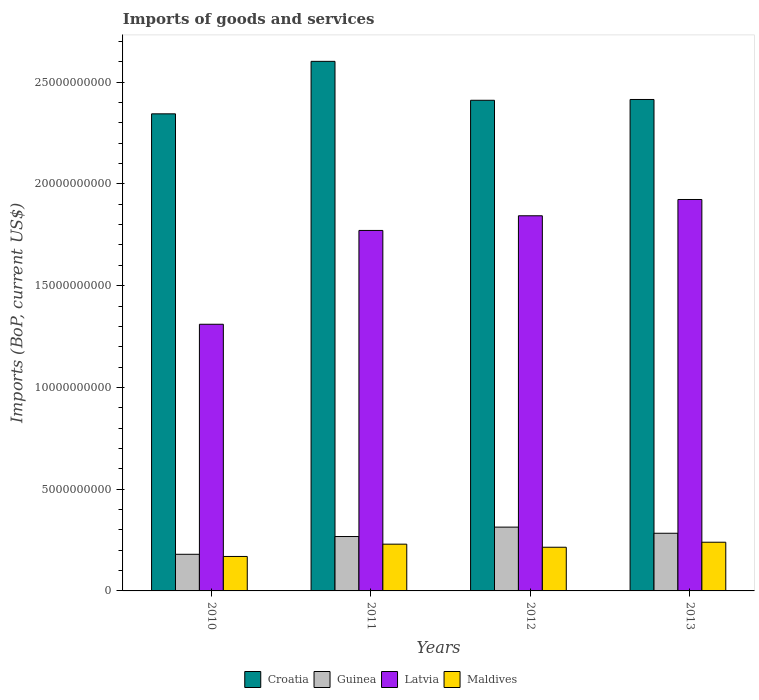Are the number of bars per tick equal to the number of legend labels?
Your response must be concise. Yes. Are the number of bars on each tick of the X-axis equal?
Your answer should be compact. Yes. What is the amount spent on imports in Guinea in 2010?
Your answer should be very brief. 1.80e+09. Across all years, what is the maximum amount spent on imports in Croatia?
Give a very brief answer. 2.60e+1. Across all years, what is the minimum amount spent on imports in Croatia?
Ensure brevity in your answer.  2.34e+1. In which year was the amount spent on imports in Maldives minimum?
Provide a succinct answer. 2010. What is the total amount spent on imports in Latvia in the graph?
Make the answer very short. 6.85e+1. What is the difference between the amount spent on imports in Maldives in 2010 and that in 2011?
Give a very brief answer. -6.05e+08. What is the difference between the amount spent on imports in Maldives in 2012 and the amount spent on imports in Latvia in 2013?
Provide a short and direct response. -1.71e+1. What is the average amount spent on imports in Latvia per year?
Keep it short and to the point. 1.71e+1. In the year 2011, what is the difference between the amount spent on imports in Guinea and amount spent on imports in Maldives?
Your answer should be compact. 3.75e+08. In how many years, is the amount spent on imports in Guinea greater than 8000000000 US$?
Your answer should be compact. 0. What is the ratio of the amount spent on imports in Latvia in 2011 to that in 2013?
Provide a succinct answer. 0.92. Is the amount spent on imports in Guinea in 2010 less than that in 2013?
Offer a very short reply. Yes. Is the difference between the amount spent on imports in Guinea in 2010 and 2013 greater than the difference between the amount spent on imports in Maldives in 2010 and 2013?
Your answer should be very brief. No. What is the difference between the highest and the second highest amount spent on imports in Guinea?
Ensure brevity in your answer.  3.02e+08. What is the difference between the highest and the lowest amount spent on imports in Maldives?
Give a very brief answer. 7.00e+08. Is the sum of the amount spent on imports in Croatia in 2010 and 2012 greater than the maximum amount spent on imports in Maldives across all years?
Your response must be concise. Yes. Is it the case that in every year, the sum of the amount spent on imports in Croatia and amount spent on imports in Guinea is greater than the sum of amount spent on imports in Maldives and amount spent on imports in Latvia?
Your answer should be very brief. Yes. What does the 3rd bar from the left in 2011 represents?
Your response must be concise. Latvia. What does the 4th bar from the right in 2010 represents?
Provide a succinct answer. Croatia. Is it the case that in every year, the sum of the amount spent on imports in Croatia and amount spent on imports in Maldives is greater than the amount spent on imports in Guinea?
Offer a very short reply. Yes. How many bars are there?
Give a very brief answer. 16. How many years are there in the graph?
Ensure brevity in your answer.  4. What is the difference between two consecutive major ticks on the Y-axis?
Your answer should be very brief. 5.00e+09. Where does the legend appear in the graph?
Offer a very short reply. Bottom center. How many legend labels are there?
Give a very brief answer. 4. How are the legend labels stacked?
Provide a short and direct response. Horizontal. What is the title of the graph?
Give a very brief answer. Imports of goods and services. What is the label or title of the Y-axis?
Keep it short and to the point. Imports (BoP, current US$). What is the Imports (BoP, current US$) in Croatia in 2010?
Ensure brevity in your answer.  2.34e+1. What is the Imports (BoP, current US$) in Guinea in 2010?
Offer a very short reply. 1.80e+09. What is the Imports (BoP, current US$) of Latvia in 2010?
Keep it short and to the point. 1.31e+1. What is the Imports (BoP, current US$) of Maldives in 2010?
Your response must be concise. 1.69e+09. What is the Imports (BoP, current US$) in Croatia in 2011?
Make the answer very short. 2.60e+1. What is the Imports (BoP, current US$) in Guinea in 2011?
Your response must be concise. 2.67e+09. What is the Imports (BoP, current US$) of Latvia in 2011?
Provide a short and direct response. 1.77e+1. What is the Imports (BoP, current US$) in Maldives in 2011?
Your answer should be compact. 2.30e+09. What is the Imports (BoP, current US$) in Croatia in 2012?
Provide a succinct answer. 2.41e+1. What is the Imports (BoP, current US$) of Guinea in 2012?
Provide a succinct answer. 3.14e+09. What is the Imports (BoP, current US$) in Latvia in 2012?
Give a very brief answer. 1.84e+1. What is the Imports (BoP, current US$) of Maldives in 2012?
Ensure brevity in your answer.  2.15e+09. What is the Imports (BoP, current US$) of Croatia in 2013?
Offer a terse response. 2.42e+1. What is the Imports (BoP, current US$) in Guinea in 2013?
Ensure brevity in your answer.  2.83e+09. What is the Imports (BoP, current US$) in Latvia in 2013?
Your response must be concise. 1.92e+1. What is the Imports (BoP, current US$) of Maldives in 2013?
Offer a terse response. 2.39e+09. Across all years, what is the maximum Imports (BoP, current US$) in Croatia?
Your answer should be very brief. 2.60e+1. Across all years, what is the maximum Imports (BoP, current US$) in Guinea?
Give a very brief answer. 3.14e+09. Across all years, what is the maximum Imports (BoP, current US$) of Latvia?
Your answer should be very brief. 1.92e+1. Across all years, what is the maximum Imports (BoP, current US$) of Maldives?
Your answer should be very brief. 2.39e+09. Across all years, what is the minimum Imports (BoP, current US$) in Croatia?
Make the answer very short. 2.34e+1. Across all years, what is the minimum Imports (BoP, current US$) of Guinea?
Your response must be concise. 1.80e+09. Across all years, what is the minimum Imports (BoP, current US$) in Latvia?
Give a very brief answer. 1.31e+1. Across all years, what is the minimum Imports (BoP, current US$) of Maldives?
Provide a succinct answer. 1.69e+09. What is the total Imports (BoP, current US$) of Croatia in the graph?
Offer a terse response. 9.77e+1. What is the total Imports (BoP, current US$) of Guinea in the graph?
Ensure brevity in your answer.  1.04e+1. What is the total Imports (BoP, current US$) in Latvia in the graph?
Provide a short and direct response. 6.85e+1. What is the total Imports (BoP, current US$) of Maldives in the graph?
Your answer should be compact. 8.53e+09. What is the difference between the Imports (BoP, current US$) in Croatia in 2010 and that in 2011?
Make the answer very short. -2.58e+09. What is the difference between the Imports (BoP, current US$) in Guinea in 2010 and that in 2011?
Make the answer very short. -8.73e+08. What is the difference between the Imports (BoP, current US$) of Latvia in 2010 and that in 2011?
Your answer should be very brief. -4.61e+09. What is the difference between the Imports (BoP, current US$) in Maldives in 2010 and that in 2011?
Make the answer very short. -6.05e+08. What is the difference between the Imports (BoP, current US$) in Croatia in 2010 and that in 2012?
Your response must be concise. -6.66e+08. What is the difference between the Imports (BoP, current US$) in Guinea in 2010 and that in 2012?
Give a very brief answer. -1.34e+09. What is the difference between the Imports (BoP, current US$) of Latvia in 2010 and that in 2012?
Offer a terse response. -5.33e+09. What is the difference between the Imports (BoP, current US$) in Maldives in 2010 and that in 2012?
Keep it short and to the point. -4.53e+08. What is the difference between the Imports (BoP, current US$) in Croatia in 2010 and that in 2013?
Your answer should be compact. -7.05e+08. What is the difference between the Imports (BoP, current US$) in Guinea in 2010 and that in 2013?
Your answer should be very brief. -1.03e+09. What is the difference between the Imports (BoP, current US$) of Latvia in 2010 and that in 2013?
Your response must be concise. -6.13e+09. What is the difference between the Imports (BoP, current US$) of Maldives in 2010 and that in 2013?
Your answer should be compact. -7.00e+08. What is the difference between the Imports (BoP, current US$) of Croatia in 2011 and that in 2012?
Your answer should be compact. 1.91e+09. What is the difference between the Imports (BoP, current US$) in Guinea in 2011 and that in 2012?
Provide a short and direct response. -4.63e+08. What is the difference between the Imports (BoP, current US$) of Latvia in 2011 and that in 2012?
Your response must be concise. -7.21e+08. What is the difference between the Imports (BoP, current US$) of Maldives in 2011 and that in 2012?
Your answer should be very brief. 1.51e+08. What is the difference between the Imports (BoP, current US$) in Croatia in 2011 and that in 2013?
Offer a terse response. 1.87e+09. What is the difference between the Imports (BoP, current US$) in Guinea in 2011 and that in 2013?
Give a very brief answer. -1.60e+08. What is the difference between the Imports (BoP, current US$) in Latvia in 2011 and that in 2013?
Give a very brief answer. -1.52e+09. What is the difference between the Imports (BoP, current US$) in Maldives in 2011 and that in 2013?
Provide a short and direct response. -9.49e+07. What is the difference between the Imports (BoP, current US$) of Croatia in 2012 and that in 2013?
Provide a short and direct response. -3.94e+07. What is the difference between the Imports (BoP, current US$) in Guinea in 2012 and that in 2013?
Provide a succinct answer. 3.02e+08. What is the difference between the Imports (BoP, current US$) in Latvia in 2012 and that in 2013?
Your answer should be compact. -8.01e+08. What is the difference between the Imports (BoP, current US$) in Maldives in 2012 and that in 2013?
Your response must be concise. -2.46e+08. What is the difference between the Imports (BoP, current US$) in Croatia in 2010 and the Imports (BoP, current US$) in Guinea in 2011?
Offer a very short reply. 2.08e+1. What is the difference between the Imports (BoP, current US$) in Croatia in 2010 and the Imports (BoP, current US$) in Latvia in 2011?
Keep it short and to the point. 5.73e+09. What is the difference between the Imports (BoP, current US$) of Croatia in 2010 and the Imports (BoP, current US$) of Maldives in 2011?
Your response must be concise. 2.11e+1. What is the difference between the Imports (BoP, current US$) in Guinea in 2010 and the Imports (BoP, current US$) in Latvia in 2011?
Offer a very short reply. -1.59e+1. What is the difference between the Imports (BoP, current US$) in Guinea in 2010 and the Imports (BoP, current US$) in Maldives in 2011?
Ensure brevity in your answer.  -4.97e+08. What is the difference between the Imports (BoP, current US$) in Latvia in 2010 and the Imports (BoP, current US$) in Maldives in 2011?
Your answer should be very brief. 1.08e+1. What is the difference between the Imports (BoP, current US$) in Croatia in 2010 and the Imports (BoP, current US$) in Guinea in 2012?
Keep it short and to the point. 2.03e+1. What is the difference between the Imports (BoP, current US$) in Croatia in 2010 and the Imports (BoP, current US$) in Latvia in 2012?
Ensure brevity in your answer.  5.01e+09. What is the difference between the Imports (BoP, current US$) of Croatia in 2010 and the Imports (BoP, current US$) of Maldives in 2012?
Ensure brevity in your answer.  2.13e+1. What is the difference between the Imports (BoP, current US$) of Guinea in 2010 and the Imports (BoP, current US$) of Latvia in 2012?
Make the answer very short. -1.66e+1. What is the difference between the Imports (BoP, current US$) of Guinea in 2010 and the Imports (BoP, current US$) of Maldives in 2012?
Your answer should be compact. -3.46e+08. What is the difference between the Imports (BoP, current US$) in Latvia in 2010 and the Imports (BoP, current US$) in Maldives in 2012?
Give a very brief answer. 1.10e+1. What is the difference between the Imports (BoP, current US$) in Croatia in 2010 and the Imports (BoP, current US$) in Guinea in 2013?
Your response must be concise. 2.06e+1. What is the difference between the Imports (BoP, current US$) in Croatia in 2010 and the Imports (BoP, current US$) in Latvia in 2013?
Provide a succinct answer. 4.21e+09. What is the difference between the Imports (BoP, current US$) in Croatia in 2010 and the Imports (BoP, current US$) in Maldives in 2013?
Your response must be concise. 2.11e+1. What is the difference between the Imports (BoP, current US$) in Guinea in 2010 and the Imports (BoP, current US$) in Latvia in 2013?
Provide a succinct answer. -1.74e+1. What is the difference between the Imports (BoP, current US$) in Guinea in 2010 and the Imports (BoP, current US$) in Maldives in 2013?
Offer a very short reply. -5.92e+08. What is the difference between the Imports (BoP, current US$) of Latvia in 2010 and the Imports (BoP, current US$) of Maldives in 2013?
Provide a short and direct response. 1.07e+1. What is the difference between the Imports (BoP, current US$) in Croatia in 2011 and the Imports (BoP, current US$) in Guinea in 2012?
Ensure brevity in your answer.  2.29e+1. What is the difference between the Imports (BoP, current US$) in Croatia in 2011 and the Imports (BoP, current US$) in Latvia in 2012?
Provide a short and direct response. 7.59e+09. What is the difference between the Imports (BoP, current US$) in Croatia in 2011 and the Imports (BoP, current US$) in Maldives in 2012?
Offer a terse response. 2.39e+1. What is the difference between the Imports (BoP, current US$) in Guinea in 2011 and the Imports (BoP, current US$) in Latvia in 2012?
Your answer should be compact. -1.58e+1. What is the difference between the Imports (BoP, current US$) in Guinea in 2011 and the Imports (BoP, current US$) in Maldives in 2012?
Offer a very short reply. 5.27e+08. What is the difference between the Imports (BoP, current US$) in Latvia in 2011 and the Imports (BoP, current US$) in Maldives in 2012?
Keep it short and to the point. 1.56e+1. What is the difference between the Imports (BoP, current US$) in Croatia in 2011 and the Imports (BoP, current US$) in Guinea in 2013?
Your answer should be compact. 2.32e+1. What is the difference between the Imports (BoP, current US$) in Croatia in 2011 and the Imports (BoP, current US$) in Latvia in 2013?
Keep it short and to the point. 6.79e+09. What is the difference between the Imports (BoP, current US$) in Croatia in 2011 and the Imports (BoP, current US$) in Maldives in 2013?
Your response must be concise. 2.36e+1. What is the difference between the Imports (BoP, current US$) in Guinea in 2011 and the Imports (BoP, current US$) in Latvia in 2013?
Your answer should be compact. -1.66e+1. What is the difference between the Imports (BoP, current US$) of Guinea in 2011 and the Imports (BoP, current US$) of Maldives in 2013?
Ensure brevity in your answer.  2.80e+08. What is the difference between the Imports (BoP, current US$) of Latvia in 2011 and the Imports (BoP, current US$) of Maldives in 2013?
Your answer should be very brief. 1.53e+1. What is the difference between the Imports (BoP, current US$) of Croatia in 2012 and the Imports (BoP, current US$) of Guinea in 2013?
Keep it short and to the point. 2.13e+1. What is the difference between the Imports (BoP, current US$) in Croatia in 2012 and the Imports (BoP, current US$) in Latvia in 2013?
Offer a terse response. 4.88e+09. What is the difference between the Imports (BoP, current US$) in Croatia in 2012 and the Imports (BoP, current US$) in Maldives in 2013?
Keep it short and to the point. 2.17e+1. What is the difference between the Imports (BoP, current US$) in Guinea in 2012 and the Imports (BoP, current US$) in Latvia in 2013?
Ensure brevity in your answer.  -1.61e+1. What is the difference between the Imports (BoP, current US$) of Guinea in 2012 and the Imports (BoP, current US$) of Maldives in 2013?
Give a very brief answer. 7.43e+08. What is the difference between the Imports (BoP, current US$) of Latvia in 2012 and the Imports (BoP, current US$) of Maldives in 2013?
Give a very brief answer. 1.60e+1. What is the average Imports (BoP, current US$) in Croatia per year?
Offer a terse response. 2.44e+1. What is the average Imports (BoP, current US$) of Guinea per year?
Provide a succinct answer. 2.61e+09. What is the average Imports (BoP, current US$) of Latvia per year?
Your response must be concise. 1.71e+1. What is the average Imports (BoP, current US$) in Maldives per year?
Your response must be concise. 2.13e+09. In the year 2010, what is the difference between the Imports (BoP, current US$) of Croatia and Imports (BoP, current US$) of Guinea?
Provide a short and direct response. 2.16e+1. In the year 2010, what is the difference between the Imports (BoP, current US$) of Croatia and Imports (BoP, current US$) of Latvia?
Make the answer very short. 1.03e+1. In the year 2010, what is the difference between the Imports (BoP, current US$) in Croatia and Imports (BoP, current US$) in Maldives?
Make the answer very short. 2.18e+1. In the year 2010, what is the difference between the Imports (BoP, current US$) of Guinea and Imports (BoP, current US$) of Latvia?
Give a very brief answer. -1.13e+1. In the year 2010, what is the difference between the Imports (BoP, current US$) in Guinea and Imports (BoP, current US$) in Maldives?
Provide a succinct answer. 1.07e+08. In the year 2010, what is the difference between the Imports (BoP, current US$) of Latvia and Imports (BoP, current US$) of Maldives?
Provide a succinct answer. 1.14e+1. In the year 2011, what is the difference between the Imports (BoP, current US$) in Croatia and Imports (BoP, current US$) in Guinea?
Offer a very short reply. 2.34e+1. In the year 2011, what is the difference between the Imports (BoP, current US$) in Croatia and Imports (BoP, current US$) in Latvia?
Provide a succinct answer. 8.31e+09. In the year 2011, what is the difference between the Imports (BoP, current US$) of Croatia and Imports (BoP, current US$) of Maldives?
Keep it short and to the point. 2.37e+1. In the year 2011, what is the difference between the Imports (BoP, current US$) of Guinea and Imports (BoP, current US$) of Latvia?
Provide a short and direct response. -1.50e+1. In the year 2011, what is the difference between the Imports (BoP, current US$) of Guinea and Imports (BoP, current US$) of Maldives?
Offer a terse response. 3.75e+08. In the year 2011, what is the difference between the Imports (BoP, current US$) of Latvia and Imports (BoP, current US$) of Maldives?
Keep it short and to the point. 1.54e+1. In the year 2012, what is the difference between the Imports (BoP, current US$) in Croatia and Imports (BoP, current US$) in Guinea?
Ensure brevity in your answer.  2.10e+1. In the year 2012, what is the difference between the Imports (BoP, current US$) of Croatia and Imports (BoP, current US$) of Latvia?
Your answer should be very brief. 5.68e+09. In the year 2012, what is the difference between the Imports (BoP, current US$) of Croatia and Imports (BoP, current US$) of Maldives?
Offer a terse response. 2.20e+1. In the year 2012, what is the difference between the Imports (BoP, current US$) in Guinea and Imports (BoP, current US$) in Latvia?
Ensure brevity in your answer.  -1.53e+1. In the year 2012, what is the difference between the Imports (BoP, current US$) in Guinea and Imports (BoP, current US$) in Maldives?
Offer a terse response. 9.89e+08. In the year 2012, what is the difference between the Imports (BoP, current US$) of Latvia and Imports (BoP, current US$) of Maldives?
Provide a succinct answer. 1.63e+1. In the year 2013, what is the difference between the Imports (BoP, current US$) of Croatia and Imports (BoP, current US$) of Guinea?
Offer a terse response. 2.13e+1. In the year 2013, what is the difference between the Imports (BoP, current US$) of Croatia and Imports (BoP, current US$) of Latvia?
Make the answer very short. 4.91e+09. In the year 2013, what is the difference between the Imports (BoP, current US$) of Croatia and Imports (BoP, current US$) of Maldives?
Provide a succinct answer. 2.18e+1. In the year 2013, what is the difference between the Imports (BoP, current US$) of Guinea and Imports (BoP, current US$) of Latvia?
Ensure brevity in your answer.  -1.64e+1. In the year 2013, what is the difference between the Imports (BoP, current US$) of Guinea and Imports (BoP, current US$) of Maldives?
Your answer should be compact. 4.41e+08. In the year 2013, what is the difference between the Imports (BoP, current US$) in Latvia and Imports (BoP, current US$) in Maldives?
Make the answer very short. 1.68e+1. What is the ratio of the Imports (BoP, current US$) of Croatia in 2010 to that in 2011?
Provide a short and direct response. 0.9. What is the ratio of the Imports (BoP, current US$) of Guinea in 2010 to that in 2011?
Provide a short and direct response. 0.67. What is the ratio of the Imports (BoP, current US$) in Latvia in 2010 to that in 2011?
Your answer should be compact. 0.74. What is the ratio of the Imports (BoP, current US$) of Maldives in 2010 to that in 2011?
Offer a terse response. 0.74. What is the ratio of the Imports (BoP, current US$) of Croatia in 2010 to that in 2012?
Ensure brevity in your answer.  0.97. What is the ratio of the Imports (BoP, current US$) in Guinea in 2010 to that in 2012?
Your answer should be very brief. 0.57. What is the ratio of the Imports (BoP, current US$) in Latvia in 2010 to that in 2012?
Provide a short and direct response. 0.71. What is the ratio of the Imports (BoP, current US$) of Maldives in 2010 to that in 2012?
Offer a very short reply. 0.79. What is the ratio of the Imports (BoP, current US$) in Croatia in 2010 to that in 2013?
Your answer should be very brief. 0.97. What is the ratio of the Imports (BoP, current US$) of Guinea in 2010 to that in 2013?
Keep it short and to the point. 0.64. What is the ratio of the Imports (BoP, current US$) of Latvia in 2010 to that in 2013?
Your answer should be very brief. 0.68. What is the ratio of the Imports (BoP, current US$) of Maldives in 2010 to that in 2013?
Offer a very short reply. 0.71. What is the ratio of the Imports (BoP, current US$) of Croatia in 2011 to that in 2012?
Ensure brevity in your answer.  1.08. What is the ratio of the Imports (BoP, current US$) in Guinea in 2011 to that in 2012?
Keep it short and to the point. 0.85. What is the ratio of the Imports (BoP, current US$) in Latvia in 2011 to that in 2012?
Provide a short and direct response. 0.96. What is the ratio of the Imports (BoP, current US$) in Maldives in 2011 to that in 2012?
Your answer should be compact. 1.07. What is the ratio of the Imports (BoP, current US$) in Croatia in 2011 to that in 2013?
Your answer should be compact. 1.08. What is the ratio of the Imports (BoP, current US$) in Guinea in 2011 to that in 2013?
Offer a very short reply. 0.94. What is the ratio of the Imports (BoP, current US$) in Latvia in 2011 to that in 2013?
Provide a succinct answer. 0.92. What is the ratio of the Imports (BoP, current US$) of Maldives in 2011 to that in 2013?
Your response must be concise. 0.96. What is the ratio of the Imports (BoP, current US$) of Croatia in 2012 to that in 2013?
Your response must be concise. 1. What is the ratio of the Imports (BoP, current US$) in Guinea in 2012 to that in 2013?
Offer a very short reply. 1.11. What is the ratio of the Imports (BoP, current US$) of Latvia in 2012 to that in 2013?
Offer a very short reply. 0.96. What is the ratio of the Imports (BoP, current US$) in Maldives in 2012 to that in 2013?
Offer a terse response. 0.9. What is the difference between the highest and the second highest Imports (BoP, current US$) of Croatia?
Your answer should be compact. 1.87e+09. What is the difference between the highest and the second highest Imports (BoP, current US$) of Guinea?
Offer a very short reply. 3.02e+08. What is the difference between the highest and the second highest Imports (BoP, current US$) of Latvia?
Your answer should be compact. 8.01e+08. What is the difference between the highest and the second highest Imports (BoP, current US$) of Maldives?
Your answer should be very brief. 9.49e+07. What is the difference between the highest and the lowest Imports (BoP, current US$) in Croatia?
Ensure brevity in your answer.  2.58e+09. What is the difference between the highest and the lowest Imports (BoP, current US$) of Guinea?
Ensure brevity in your answer.  1.34e+09. What is the difference between the highest and the lowest Imports (BoP, current US$) of Latvia?
Keep it short and to the point. 6.13e+09. What is the difference between the highest and the lowest Imports (BoP, current US$) of Maldives?
Offer a terse response. 7.00e+08. 